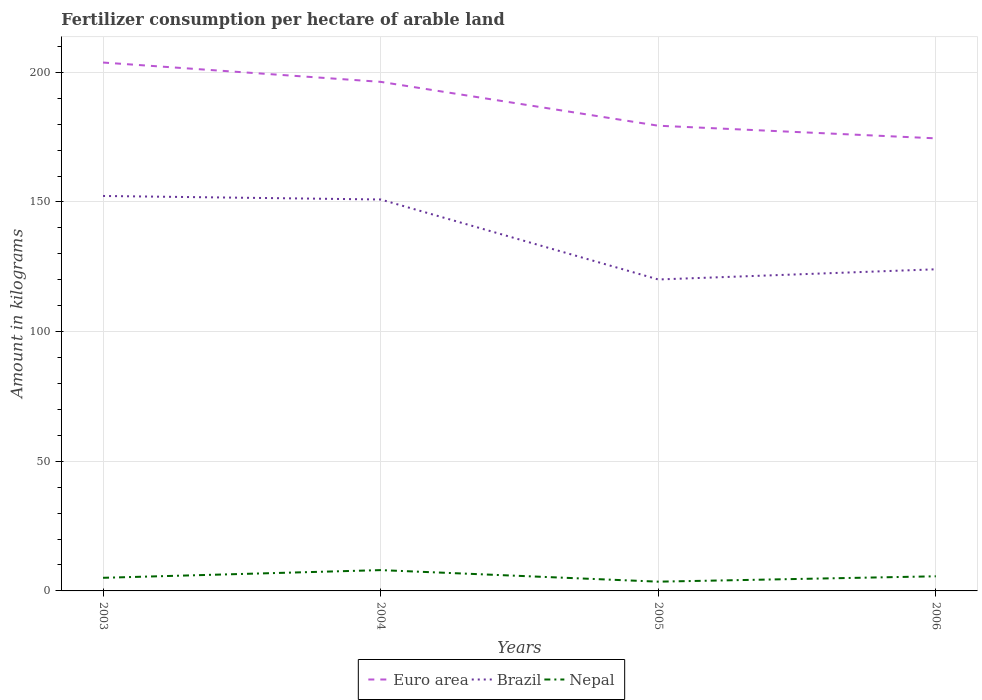Does the line corresponding to Euro area intersect with the line corresponding to Nepal?
Offer a very short reply. No. Across all years, what is the maximum amount of fertilizer consumption in Nepal?
Make the answer very short. 3.57. What is the total amount of fertilizer consumption in Brazil in the graph?
Give a very brief answer. 26.91. What is the difference between the highest and the second highest amount of fertilizer consumption in Nepal?
Provide a short and direct response. 4.46. How many years are there in the graph?
Give a very brief answer. 4. What is the difference between two consecutive major ticks on the Y-axis?
Your answer should be compact. 50. Are the values on the major ticks of Y-axis written in scientific E-notation?
Your response must be concise. No. Does the graph contain any zero values?
Offer a terse response. No. Where does the legend appear in the graph?
Your answer should be very brief. Bottom center. How many legend labels are there?
Your answer should be very brief. 3. How are the legend labels stacked?
Give a very brief answer. Horizontal. What is the title of the graph?
Keep it short and to the point. Fertilizer consumption per hectare of arable land. Does "Peru" appear as one of the legend labels in the graph?
Give a very brief answer. No. What is the label or title of the Y-axis?
Your answer should be very brief. Amount in kilograms. What is the Amount in kilograms of Euro area in 2003?
Ensure brevity in your answer.  203.76. What is the Amount in kilograms in Brazil in 2003?
Ensure brevity in your answer.  152.31. What is the Amount in kilograms of Nepal in 2003?
Keep it short and to the point. 5.06. What is the Amount in kilograms in Euro area in 2004?
Make the answer very short. 196.31. What is the Amount in kilograms of Brazil in 2004?
Your response must be concise. 150.95. What is the Amount in kilograms in Nepal in 2004?
Offer a terse response. 8.03. What is the Amount in kilograms of Euro area in 2005?
Make the answer very short. 179.4. What is the Amount in kilograms of Brazil in 2005?
Your response must be concise. 120.1. What is the Amount in kilograms in Nepal in 2005?
Offer a very short reply. 3.57. What is the Amount in kilograms of Euro area in 2006?
Offer a terse response. 174.52. What is the Amount in kilograms in Brazil in 2006?
Provide a succinct answer. 124.03. What is the Amount in kilograms in Nepal in 2006?
Ensure brevity in your answer.  5.64. Across all years, what is the maximum Amount in kilograms in Euro area?
Offer a terse response. 203.76. Across all years, what is the maximum Amount in kilograms of Brazil?
Make the answer very short. 152.31. Across all years, what is the maximum Amount in kilograms of Nepal?
Give a very brief answer. 8.03. Across all years, what is the minimum Amount in kilograms in Euro area?
Provide a succinct answer. 174.52. Across all years, what is the minimum Amount in kilograms of Brazil?
Offer a very short reply. 120.1. Across all years, what is the minimum Amount in kilograms of Nepal?
Offer a very short reply. 3.57. What is the total Amount in kilograms in Euro area in the graph?
Offer a terse response. 753.99. What is the total Amount in kilograms of Brazil in the graph?
Provide a short and direct response. 547.38. What is the total Amount in kilograms of Nepal in the graph?
Your answer should be very brief. 22.29. What is the difference between the Amount in kilograms in Euro area in 2003 and that in 2004?
Your answer should be compact. 7.45. What is the difference between the Amount in kilograms of Brazil in 2003 and that in 2004?
Ensure brevity in your answer.  1.36. What is the difference between the Amount in kilograms in Nepal in 2003 and that in 2004?
Your response must be concise. -2.97. What is the difference between the Amount in kilograms in Euro area in 2003 and that in 2005?
Make the answer very short. 24.37. What is the difference between the Amount in kilograms of Brazil in 2003 and that in 2005?
Give a very brief answer. 32.2. What is the difference between the Amount in kilograms in Nepal in 2003 and that in 2005?
Offer a terse response. 1.49. What is the difference between the Amount in kilograms of Euro area in 2003 and that in 2006?
Make the answer very short. 29.24. What is the difference between the Amount in kilograms of Brazil in 2003 and that in 2006?
Ensure brevity in your answer.  28.27. What is the difference between the Amount in kilograms of Nepal in 2003 and that in 2006?
Ensure brevity in your answer.  -0.58. What is the difference between the Amount in kilograms of Euro area in 2004 and that in 2005?
Keep it short and to the point. 16.92. What is the difference between the Amount in kilograms in Brazil in 2004 and that in 2005?
Give a very brief answer. 30.85. What is the difference between the Amount in kilograms of Nepal in 2004 and that in 2005?
Offer a terse response. 4.46. What is the difference between the Amount in kilograms of Euro area in 2004 and that in 2006?
Ensure brevity in your answer.  21.79. What is the difference between the Amount in kilograms of Brazil in 2004 and that in 2006?
Provide a succinct answer. 26.91. What is the difference between the Amount in kilograms of Nepal in 2004 and that in 2006?
Your response must be concise. 2.38. What is the difference between the Amount in kilograms in Euro area in 2005 and that in 2006?
Your answer should be compact. 4.87. What is the difference between the Amount in kilograms of Brazil in 2005 and that in 2006?
Your response must be concise. -3.93. What is the difference between the Amount in kilograms in Nepal in 2005 and that in 2006?
Provide a short and direct response. -2.07. What is the difference between the Amount in kilograms of Euro area in 2003 and the Amount in kilograms of Brazil in 2004?
Provide a short and direct response. 52.82. What is the difference between the Amount in kilograms of Euro area in 2003 and the Amount in kilograms of Nepal in 2004?
Your answer should be very brief. 195.74. What is the difference between the Amount in kilograms of Brazil in 2003 and the Amount in kilograms of Nepal in 2004?
Your answer should be compact. 144.28. What is the difference between the Amount in kilograms of Euro area in 2003 and the Amount in kilograms of Brazil in 2005?
Keep it short and to the point. 83.66. What is the difference between the Amount in kilograms in Euro area in 2003 and the Amount in kilograms in Nepal in 2005?
Give a very brief answer. 200.19. What is the difference between the Amount in kilograms in Brazil in 2003 and the Amount in kilograms in Nepal in 2005?
Make the answer very short. 148.74. What is the difference between the Amount in kilograms in Euro area in 2003 and the Amount in kilograms in Brazil in 2006?
Offer a very short reply. 79.73. What is the difference between the Amount in kilograms in Euro area in 2003 and the Amount in kilograms in Nepal in 2006?
Make the answer very short. 198.12. What is the difference between the Amount in kilograms of Brazil in 2003 and the Amount in kilograms of Nepal in 2006?
Your response must be concise. 146.66. What is the difference between the Amount in kilograms of Euro area in 2004 and the Amount in kilograms of Brazil in 2005?
Your response must be concise. 76.21. What is the difference between the Amount in kilograms of Euro area in 2004 and the Amount in kilograms of Nepal in 2005?
Make the answer very short. 192.74. What is the difference between the Amount in kilograms in Brazil in 2004 and the Amount in kilograms in Nepal in 2005?
Your answer should be very brief. 147.38. What is the difference between the Amount in kilograms of Euro area in 2004 and the Amount in kilograms of Brazil in 2006?
Your answer should be compact. 72.28. What is the difference between the Amount in kilograms in Euro area in 2004 and the Amount in kilograms in Nepal in 2006?
Give a very brief answer. 190.67. What is the difference between the Amount in kilograms in Brazil in 2004 and the Amount in kilograms in Nepal in 2006?
Your answer should be very brief. 145.3. What is the difference between the Amount in kilograms in Euro area in 2005 and the Amount in kilograms in Brazil in 2006?
Ensure brevity in your answer.  55.36. What is the difference between the Amount in kilograms in Euro area in 2005 and the Amount in kilograms in Nepal in 2006?
Provide a short and direct response. 173.75. What is the difference between the Amount in kilograms in Brazil in 2005 and the Amount in kilograms in Nepal in 2006?
Make the answer very short. 114.46. What is the average Amount in kilograms of Euro area per year?
Provide a succinct answer. 188.5. What is the average Amount in kilograms of Brazil per year?
Make the answer very short. 136.85. What is the average Amount in kilograms in Nepal per year?
Your answer should be compact. 5.57. In the year 2003, what is the difference between the Amount in kilograms in Euro area and Amount in kilograms in Brazil?
Provide a succinct answer. 51.46. In the year 2003, what is the difference between the Amount in kilograms of Euro area and Amount in kilograms of Nepal?
Make the answer very short. 198.7. In the year 2003, what is the difference between the Amount in kilograms in Brazil and Amount in kilograms in Nepal?
Provide a short and direct response. 147.25. In the year 2004, what is the difference between the Amount in kilograms of Euro area and Amount in kilograms of Brazil?
Your response must be concise. 45.37. In the year 2004, what is the difference between the Amount in kilograms in Euro area and Amount in kilograms in Nepal?
Provide a short and direct response. 188.29. In the year 2004, what is the difference between the Amount in kilograms of Brazil and Amount in kilograms of Nepal?
Keep it short and to the point. 142.92. In the year 2005, what is the difference between the Amount in kilograms in Euro area and Amount in kilograms in Brazil?
Ensure brevity in your answer.  59.3. In the year 2005, what is the difference between the Amount in kilograms of Euro area and Amount in kilograms of Nepal?
Make the answer very short. 175.83. In the year 2005, what is the difference between the Amount in kilograms in Brazil and Amount in kilograms in Nepal?
Your response must be concise. 116.53. In the year 2006, what is the difference between the Amount in kilograms in Euro area and Amount in kilograms in Brazil?
Offer a very short reply. 50.49. In the year 2006, what is the difference between the Amount in kilograms of Euro area and Amount in kilograms of Nepal?
Offer a very short reply. 168.88. In the year 2006, what is the difference between the Amount in kilograms in Brazil and Amount in kilograms in Nepal?
Your answer should be very brief. 118.39. What is the ratio of the Amount in kilograms of Euro area in 2003 to that in 2004?
Your answer should be compact. 1.04. What is the ratio of the Amount in kilograms in Brazil in 2003 to that in 2004?
Provide a short and direct response. 1.01. What is the ratio of the Amount in kilograms of Nepal in 2003 to that in 2004?
Your answer should be very brief. 0.63. What is the ratio of the Amount in kilograms in Euro area in 2003 to that in 2005?
Make the answer very short. 1.14. What is the ratio of the Amount in kilograms in Brazil in 2003 to that in 2005?
Provide a succinct answer. 1.27. What is the ratio of the Amount in kilograms of Nepal in 2003 to that in 2005?
Your answer should be compact. 1.42. What is the ratio of the Amount in kilograms in Euro area in 2003 to that in 2006?
Ensure brevity in your answer.  1.17. What is the ratio of the Amount in kilograms in Brazil in 2003 to that in 2006?
Keep it short and to the point. 1.23. What is the ratio of the Amount in kilograms in Nepal in 2003 to that in 2006?
Your response must be concise. 0.9. What is the ratio of the Amount in kilograms of Euro area in 2004 to that in 2005?
Make the answer very short. 1.09. What is the ratio of the Amount in kilograms of Brazil in 2004 to that in 2005?
Provide a succinct answer. 1.26. What is the ratio of the Amount in kilograms of Nepal in 2004 to that in 2005?
Provide a short and direct response. 2.25. What is the ratio of the Amount in kilograms in Euro area in 2004 to that in 2006?
Provide a short and direct response. 1.12. What is the ratio of the Amount in kilograms of Brazil in 2004 to that in 2006?
Keep it short and to the point. 1.22. What is the ratio of the Amount in kilograms of Nepal in 2004 to that in 2006?
Your response must be concise. 1.42. What is the ratio of the Amount in kilograms in Euro area in 2005 to that in 2006?
Your answer should be compact. 1.03. What is the ratio of the Amount in kilograms of Brazil in 2005 to that in 2006?
Offer a very short reply. 0.97. What is the ratio of the Amount in kilograms of Nepal in 2005 to that in 2006?
Your answer should be very brief. 0.63. What is the difference between the highest and the second highest Amount in kilograms in Euro area?
Ensure brevity in your answer.  7.45. What is the difference between the highest and the second highest Amount in kilograms in Brazil?
Your response must be concise. 1.36. What is the difference between the highest and the second highest Amount in kilograms in Nepal?
Your answer should be very brief. 2.38. What is the difference between the highest and the lowest Amount in kilograms of Euro area?
Provide a succinct answer. 29.24. What is the difference between the highest and the lowest Amount in kilograms of Brazil?
Offer a very short reply. 32.2. What is the difference between the highest and the lowest Amount in kilograms of Nepal?
Your answer should be compact. 4.46. 